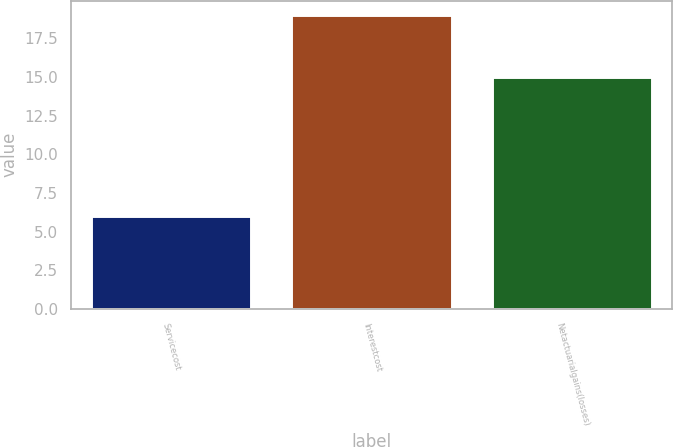<chart> <loc_0><loc_0><loc_500><loc_500><bar_chart><fcel>Servicecost<fcel>Interestcost<fcel>Netactuarialgains(losses)<nl><fcel>6<fcel>19<fcel>15<nl></chart> 